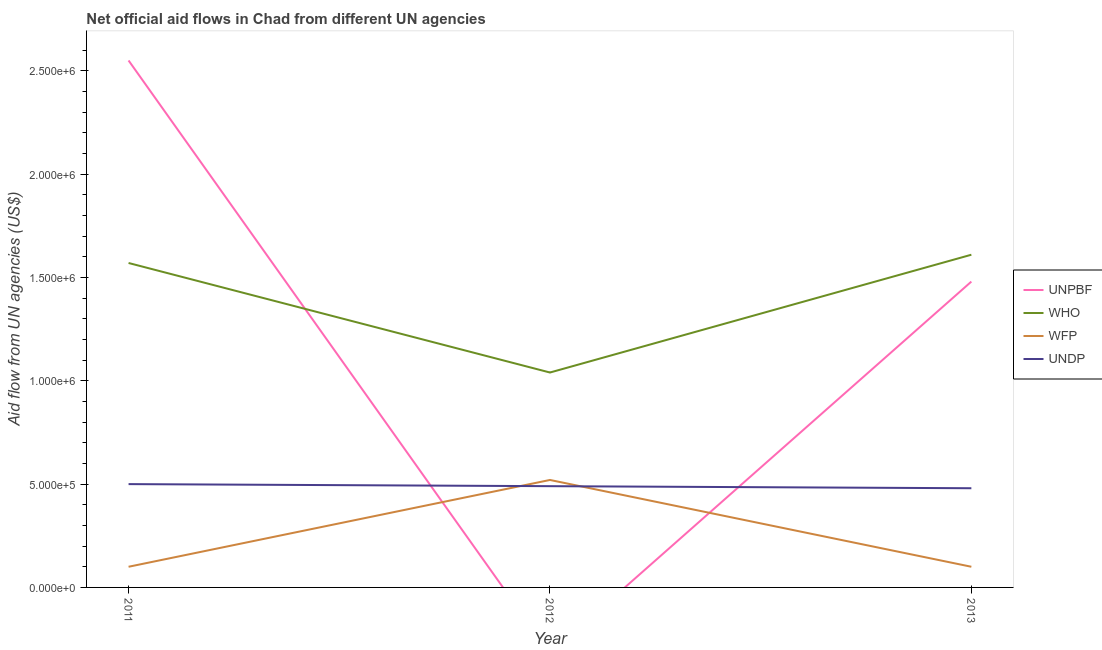Does the line corresponding to amount of aid given by unpbf intersect with the line corresponding to amount of aid given by wfp?
Provide a short and direct response. Yes. What is the amount of aid given by undp in 2012?
Your answer should be very brief. 4.90e+05. Across all years, what is the maximum amount of aid given by undp?
Give a very brief answer. 5.00e+05. Across all years, what is the minimum amount of aid given by unpbf?
Your response must be concise. 0. What is the total amount of aid given by unpbf in the graph?
Offer a very short reply. 4.03e+06. What is the difference between the amount of aid given by who in 2011 and that in 2013?
Your answer should be very brief. -4.00e+04. What is the difference between the amount of aid given by undp in 2012 and the amount of aid given by wfp in 2013?
Ensure brevity in your answer.  3.90e+05. In the year 2013, what is the difference between the amount of aid given by wfp and amount of aid given by who?
Keep it short and to the point. -1.51e+06. In how many years, is the amount of aid given by undp greater than 500000 US$?
Make the answer very short. 0. What is the ratio of the amount of aid given by wfp in 2011 to that in 2013?
Keep it short and to the point. 1. Is the difference between the amount of aid given by who in 2011 and 2013 greater than the difference between the amount of aid given by undp in 2011 and 2013?
Make the answer very short. No. What is the difference between the highest and the second highest amount of aid given by wfp?
Provide a succinct answer. 4.20e+05. What is the difference between the highest and the lowest amount of aid given by who?
Your response must be concise. 5.70e+05. In how many years, is the amount of aid given by who greater than the average amount of aid given by who taken over all years?
Ensure brevity in your answer.  2. Is the sum of the amount of aid given by wfp in 2011 and 2013 greater than the maximum amount of aid given by who across all years?
Your response must be concise. No. Is the amount of aid given by wfp strictly greater than the amount of aid given by who over the years?
Your answer should be compact. No. Is the amount of aid given by wfp strictly less than the amount of aid given by who over the years?
Offer a terse response. Yes. How many years are there in the graph?
Ensure brevity in your answer.  3. What is the difference between two consecutive major ticks on the Y-axis?
Provide a succinct answer. 5.00e+05. Are the values on the major ticks of Y-axis written in scientific E-notation?
Offer a very short reply. Yes. Does the graph contain grids?
Your response must be concise. No. How are the legend labels stacked?
Offer a terse response. Vertical. What is the title of the graph?
Keep it short and to the point. Net official aid flows in Chad from different UN agencies. Does "Third 20% of population" appear as one of the legend labels in the graph?
Ensure brevity in your answer.  No. What is the label or title of the Y-axis?
Provide a short and direct response. Aid flow from UN agencies (US$). What is the Aid flow from UN agencies (US$) of UNPBF in 2011?
Offer a very short reply. 2.55e+06. What is the Aid flow from UN agencies (US$) of WHO in 2011?
Your response must be concise. 1.57e+06. What is the Aid flow from UN agencies (US$) in UNDP in 2011?
Ensure brevity in your answer.  5.00e+05. What is the Aid flow from UN agencies (US$) of WHO in 2012?
Provide a short and direct response. 1.04e+06. What is the Aid flow from UN agencies (US$) of WFP in 2012?
Your answer should be very brief. 5.20e+05. What is the Aid flow from UN agencies (US$) in UNPBF in 2013?
Your answer should be compact. 1.48e+06. What is the Aid flow from UN agencies (US$) of WHO in 2013?
Provide a short and direct response. 1.61e+06. Across all years, what is the maximum Aid flow from UN agencies (US$) in UNPBF?
Provide a succinct answer. 2.55e+06. Across all years, what is the maximum Aid flow from UN agencies (US$) in WHO?
Your response must be concise. 1.61e+06. Across all years, what is the maximum Aid flow from UN agencies (US$) of WFP?
Ensure brevity in your answer.  5.20e+05. Across all years, what is the minimum Aid flow from UN agencies (US$) in UNPBF?
Your answer should be very brief. 0. Across all years, what is the minimum Aid flow from UN agencies (US$) of WHO?
Your answer should be compact. 1.04e+06. What is the total Aid flow from UN agencies (US$) in UNPBF in the graph?
Your answer should be compact. 4.03e+06. What is the total Aid flow from UN agencies (US$) in WHO in the graph?
Your answer should be compact. 4.22e+06. What is the total Aid flow from UN agencies (US$) in WFP in the graph?
Provide a succinct answer. 7.20e+05. What is the total Aid flow from UN agencies (US$) of UNDP in the graph?
Your answer should be compact. 1.47e+06. What is the difference between the Aid flow from UN agencies (US$) of WHO in 2011 and that in 2012?
Make the answer very short. 5.30e+05. What is the difference between the Aid flow from UN agencies (US$) of WFP in 2011 and that in 2012?
Your response must be concise. -4.20e+05. What is the difference between the Aid flow from UN agencies (US$) of UNDP in 2011 and that in 2012?
Ensure brevity in your answer.  10000. What is the difference between the Aid flow from UN agencies (US$) of UNPBF in 2011 and that in 2013?
Ensure brevity in your answer.  1.07e+06. What is the difference between the Aid flow from UN agencies (US$) of WHO in 2011 and that in 2013?
Give a very brief answer. -4.00e+04. What is the difference between the Aid flow from UN agencies (US$) in UNDP in 2011 and that in 2013?
Provide a short and direct response. 2.00e+04. What is the difference between the Aid flow from UN agencies (US$) in WHO in 2012 and that in 2013?
Give a very brief answer. -5.70e+05. What is the difference between the Aid flow from UN agencies (US$) of WFP in 2012 and that in 2013?
Offer a very short reply. 4.20e+05. What is the difference between the Aid flow from UN agencies (US$) in UNDP in 2012 and that in 2013?
Your response must be concise. 10000. What is the difference between the Aid flow from UN agencies (US$) in UNPBF in 2011 and the Aid flow from UN agencies (US$) in WHO in 2012?
Make the answer very short. 1.51e+06. What is the difference between the Aid flow from UN agencies (US$) of UNPBF in 2011 and the Aid flow from UN agencies (US$) of WFP in 2012?
Offer a very short reply. 2.03e+06. What is the difference between the Aid flow from UN agencies (US$) of UNPBF in 2011 and the Aid flow from UN agencies (US$) of UNDP in 2012?
Ensure brevity in your answer.  2.06e+06. What is the difference between the Aid flow from UN agencies (US$) of WHO in 2011 and the Aid flow from UN agencies (US$) of WFP in 2012?
Offer a terse response. 1.05e+06. What is the difference between the Aid flow from UN agencies (US$) of WHO in 2011 and the Aid flow from UN agencies (US$) of UNDP in 2012?
Give a very brief answer. 1.08e+06. What is the difference between the Aid flow from UN agencies (US$) in WFP in 2011 and the Aid flow from UN agencies (US$) in UNDP in 2012?
Your answer should be very brief. -3.90e+05. What is the difference between the Aid flow from UN agencies (US$) of UNPBF in 2011 and the Aid flow from UN agencies (US$) of WHO in 2013?
Provide a succinct answer. 9.40e+05. What is the difference between the Aid flow from UN agencies (US$) of UNPBF in 2011 and the Aid flow from UN agencies (US$) of WFP in 2013?
Your answer should be very brief. 2.45e+06. What is the difference between the Aid flow from UN agencies (US$) of UNPBF in 2011 and the Aid flow from UN agencies (US$) of UNDP in 2013?
Provide a succinct answer. 2.07e+06. What is the difference between the Aid flow from UN agencies (US$) of WHO in 2011 and the Aid flow from UN agencies (US$) of WFP in 2013?
Offer a very short reply. 1.47e+06. What is the difference between the Aid flow from UN agencies (US$) in WHO in 2011 and the Aid flow from UN agencies (US$) in UNDP in 2013?
Offer a very short reply. 1.09e+06. What is the difference between the Aid flow from UN agencies (US$) of WFP in 2011 and the Aid flow from UN agencies (US$) of UNDP in 2013?
Your answer should be very brief. -3.80e+05. What is the difference between the Aid flow from UN agencies (US$) of WHO in 2012 and the Aid flow from UN agencies (US$) of WFP in 2013?
Keep it short and to the point. 9.40e+05. What is the difference between the Aid flow from UN agencies (US$) of WHO in 2012 and the Aid flow from UN agencies (US$) of UNDP in 2013?
Your response must be concise. 5.60e+05. What is the average Aid flow from UN agencies (US$) in UNPBF per year?
Give a very brief answer. 1.34e+06. What is the average Aid flow from UN agencies (US$) of WHO per year?
Give a very brief answer. 1.41e+06. What is the average Aid flow from UN agencies (US$) of WFP per year?
Your response must be concise. 2.40e+05. What is the average Aid flow from UN agencies (US$) of UNDP per year?
Ensure brevity in your answer.  4.90e+05. In the year 2011, what is the difference between the Aid flow from UN agencies (US$) of UNPBF and Aid flow from UN agencies (US$) of WHO?
Keep it short and to the point. 9.80e+05. In the year 2011, what is the difference between the Aid flow from UN agencies (US$) of UNPBF and Aid flow from UN agencies (US$) of WFP?
Your answer should be very brief. 2.45e+06. In the year 2011, what is the difference between the Aid flow from UN agencies (US$) of UNPBF and Aid flow from UN agencies (US$) of UNDP?
Your answer should be very brief. 2.05e+06. In the year 2011, what is the difference between the Aid flow from UN agencies (US$) of WHO and Aid flow from UN agencies (US$) of WFP?
Offer a very short reply. 1.47e+06. In the year 2011, what is the difference between the Aid flow from UN agencies (US$) in WHO and Aid flow from UN agencies (US$) in UNDP?
Your answer should be compact. 1.07e+06. In the year 2011, what is the difference between the Aid flow from UN agencies (US$) in WFP and Aid flow from UN agencies (US$) in UNDP?
Ensure brevity in your answer.  -4.00e+05. In the year 2012, what is the difference between the Aid flow from UN agencies (US$) in WHO and Aid flow from UN agencies (US$) in WFP?
Keep it short and to the point. 5.20e+05. In the year 2012, what is the difference between the Aid flow from UN agencies (US$) in WHO and Aid flow from UN agencies (US$) in UNDP?
Your answer should be very brief. 5.50e+05. In the year 2013, what is the difference between the Aid flow from UN agencies (US$) of UNPBF and Aid flow from UN agencies (US$) of WHO?
Your answer should be compact. -1.30e+05. In the year 2013, what is the difference between the Aid flow from UN agencies (US$) in UNPBF and Aid flow from UN agencies (US$) in WFP?
Offer a terse response. 1.38e+06. In the year 2013, what is the difference between the Aid flow from UN agencies (US$) in WHO and Aid flow from UN agencies (US$) in WFP?
Offer a very short reply. 1.51e+06. In the year 2013, what is the difference between the Aid flow from UN agencies (US$) of WHO and Aid flow from UN agencies (US$) of UNDP?
Your answer should be very brief. 1.13e+06. In the year 2013, what is the difference between the Aid flow from UN agencies (US$) of WFP and Aid flow from UN agencies (US$) of UNDP?
Provide a short and direct response. -3.80e+05. What is the ratio of the Aid flow from UN agencies (US$) in WHO in 2011 to that in 2012?
Your answer should be compact. 1.51. What is the ratio of the Aid flow from UN agencies (US$) of WFP in 2011 to that in 2012?
Your response must be concise. 0.19. What is the ratio of the Aid flow from UN agencies (US$) of UNDP in 2011 to that in 2012?
Provide a succinct answer. 1.02. What is the ratio of the Aid flow from UN agencies (US$) in UNPBF in 2011 to that in 2013?
Offer a very short reply. 1.72. What is the ratio of the Aid flow from UN agencies (US$) of WHO in 2011 to that in 2013?
Make the answer very short. 0.98. What is the ratio of the Aid flow from UN agencies (US$) of UNDP in 2011 to that in 2013?
Your answer should be very brief. 1.04. What is the ratio of the Aid flow from UN agencies (US$) of WHO in 2012 to that in 2013?
Your response must be concise. 0.65. What is the ratio of the Aid flow from UN agencies (US$) of UNDP in 2012 to that in 2013?
Offer a very short reply. 1.02. What is the difference between the highest and the second highest Aid flow from UN agencies (US$) in WFP?
Ensure brevity in your answer.  4.20e+05. What is the difference between the highest and the second highest Aid flow from UN agencies (US$) in UNDP?
Make the answer very short. 10000. What is the difference between the highest and the lowest Aid flow from UN agencies (US$) in UNPBF?
Your answer should be very brief. 2.55e+06. What is the difference between the highest and the lowest Aid flow from UN agencies (US$) in WHO?
Your response must be concise. 5.70e+05. What is the difference between the highest and the lowest Aid flow from UN agencies (US$) in WFP?
Offer a terse response. 4.20e+05. 